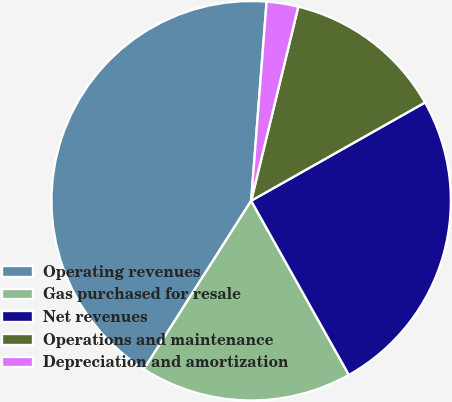Convert chart. <chart><loc_0><loc_0><loc_500><loc_500><pie_chart><fcel>Operating revenues<fcel>Gas purchased for resale<fcel>Net revenues<fcel>Operations and maintenance<fcel>Depreciation and amortization<nl><fcel>42.21%<fcel>17.16%<fcel>25.05%<fcel>13.02%<fcel>2.56%<nl></chart> 